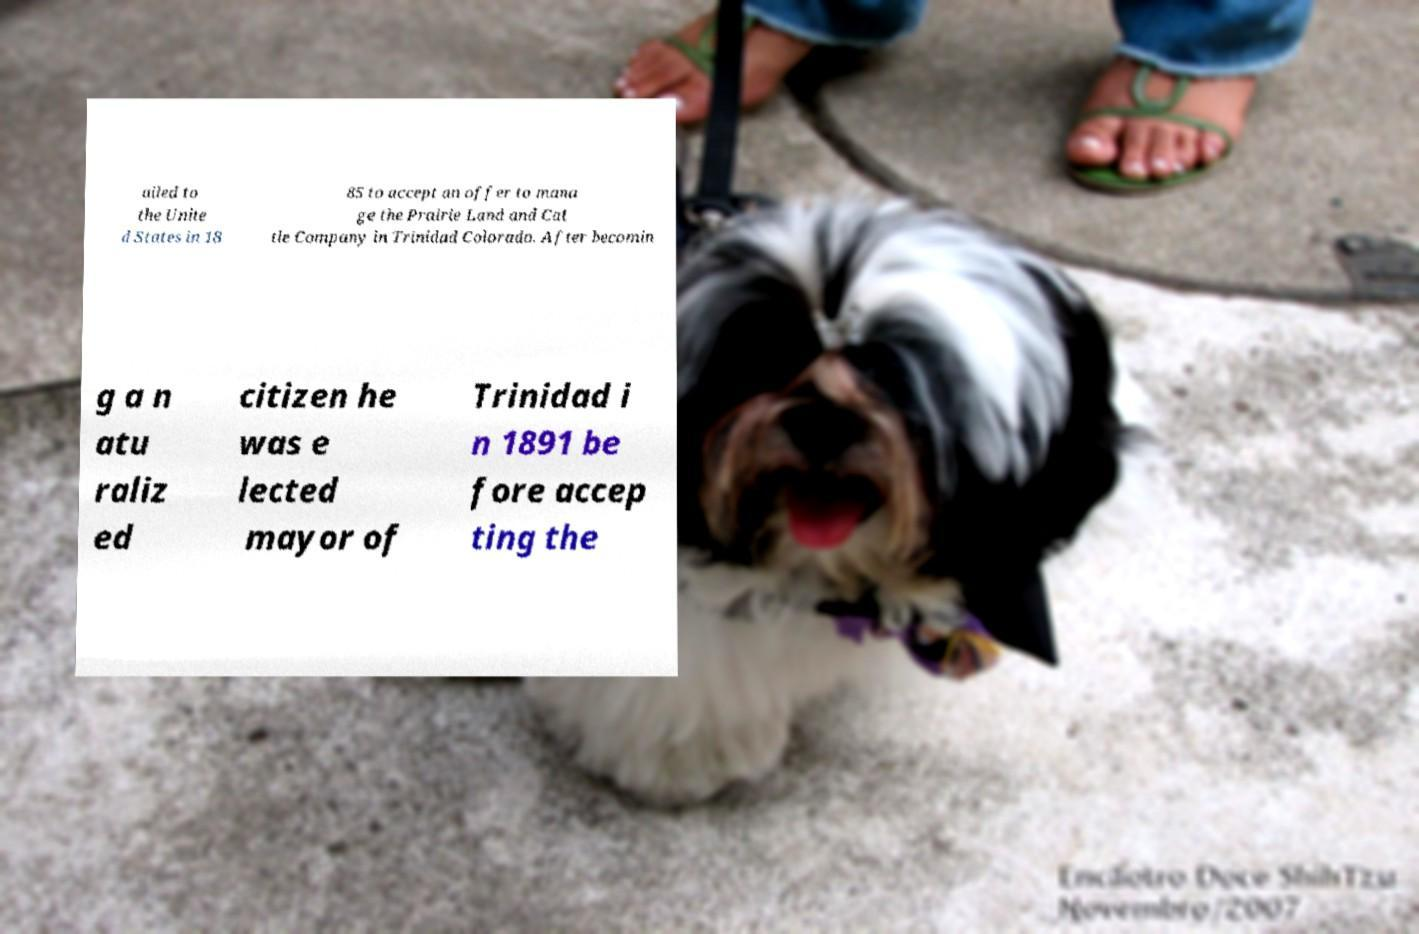Please identify and transcribe the text found in this image. ailed to the Unite d States in 18 85 to accept an offer to mana ge the Prairie Land and Cat tle Company in Trinidad Colorado. After becomin g a n atu raliz ed citizen he was e lected mayor of Trinidad i n 1891 be fore accep ting the 